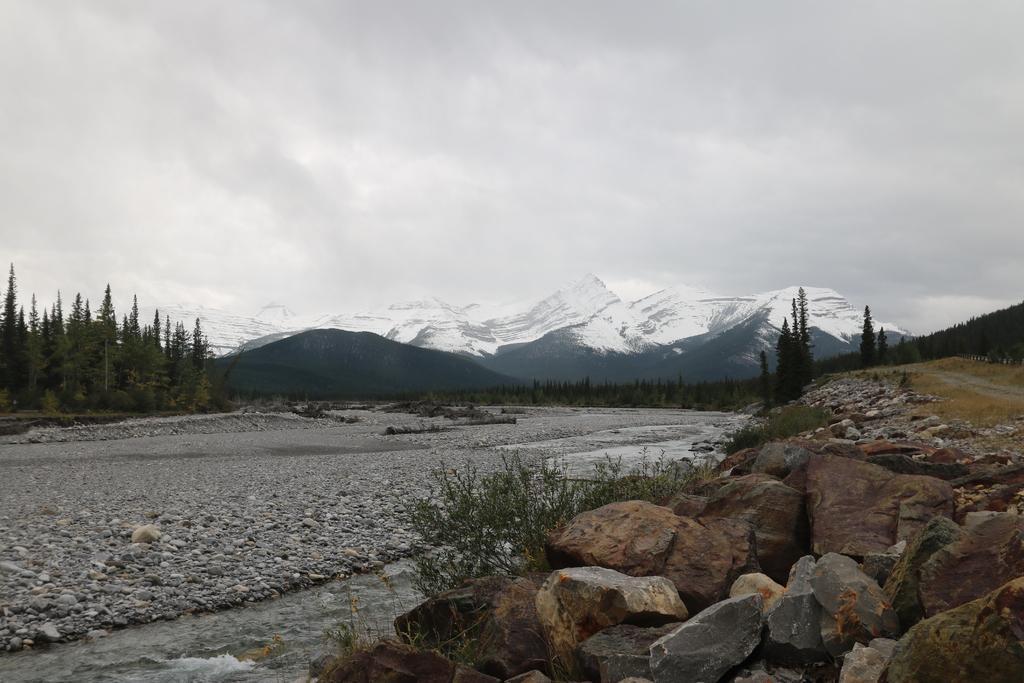Describe this image in one or two sentences. In this image in the center there are stones on the ground. In the background there are mountains, trees, and the sky is cloudy. 